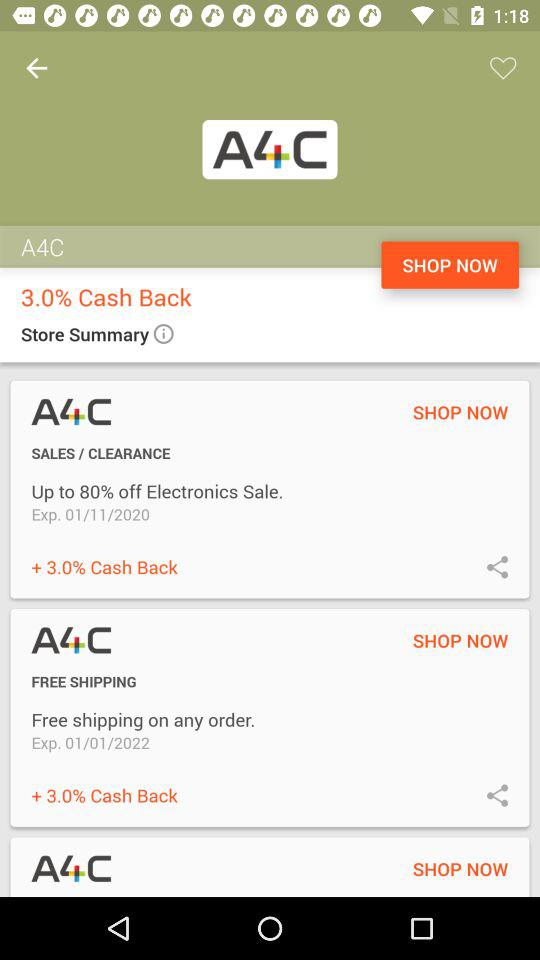What is the percentage off on the electronics sale? The percentage off on the electronics sale is up to 80. 